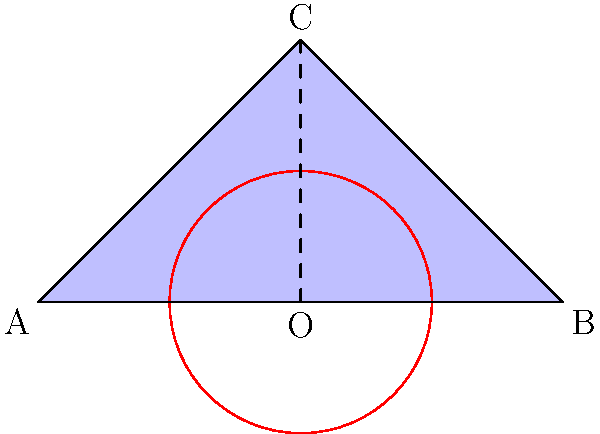In a reality TV show set design, you want to create an illusion of a larger space using hyperbolic geometry. If the set is modeled after the Poincaré disk model, where the circle represents the boundary of the hyperbolic plane, how would the triangle ABC appear to contestants inside this hyperbolic space compared to our Euclidean perception? To understand how the triangle ABC would appear in hyperbolic space, we need to consider the properties of the Poincaré disk model:

1. In the Poincaré disk model, the entire hyperbolic plane is represented within a circular disk.

2. Straight lines in hyperbolic geometry are represented by either:
   a) Diameters of the boundary circle
   b) Circular arcs that intersect the boundary circle at right angles

3. As objects get closer to the boundary of the disk, they appear to shrink from our Euclidean perspective, but maintain their actual size in hyperbolic space.

4. The boundary circle represents points at infinity in the hyperbolic plane.

Given these properties:

5. The triangle ABC would appear to have curved sides in hyperbolic space, as straight lines are represented by circular arcs.

6. The triangle would appear larger to contestants inside the hyperbolic space than it does to us in the Euclidean representation.

7. If the contestants were to walk towards the vertices of the triangle, they would feel like they're covering more distance than what we perceive in the Euclidean model.

8. The angles of the triangle would sum to less than 180 degrees in hyperbolic geometry, contrary to Euclidean geometry.

9. This effect could be used to create the illusion of a much larger set, as distances near the edge of the disk would seem much greater to the contestants than they appear to us.
Answer: The triangle would appear larger with curved sides, creating an illusion of expanded space. 